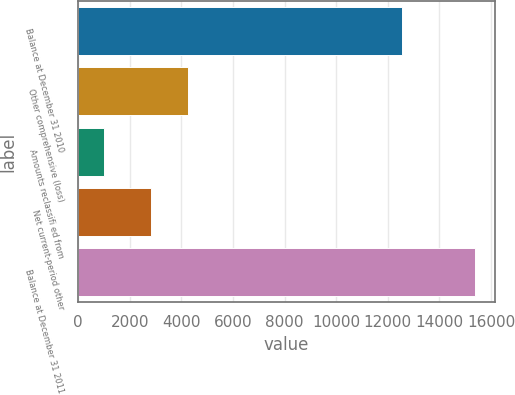Convert chart to OTSL. <chart><loc_0><loc_0><loc_500><loc_500><bar_chart><fcel>Balance at December 31 2010<fcel>Other comprehensive (loss)<fcel>Amounts reclassifi ed from<fcel>Net current-period other<fcel>Balance at December 31 2011<nl><fcel>12568<fcel>4258.3<fcel>994<fcel>2819<fcel>15387<nl></chart> 